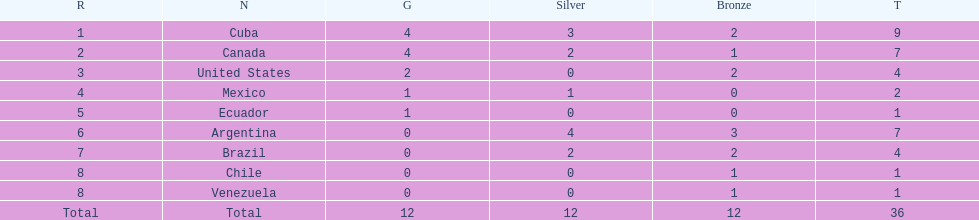Which nation won gold but did not win silver? United States. 